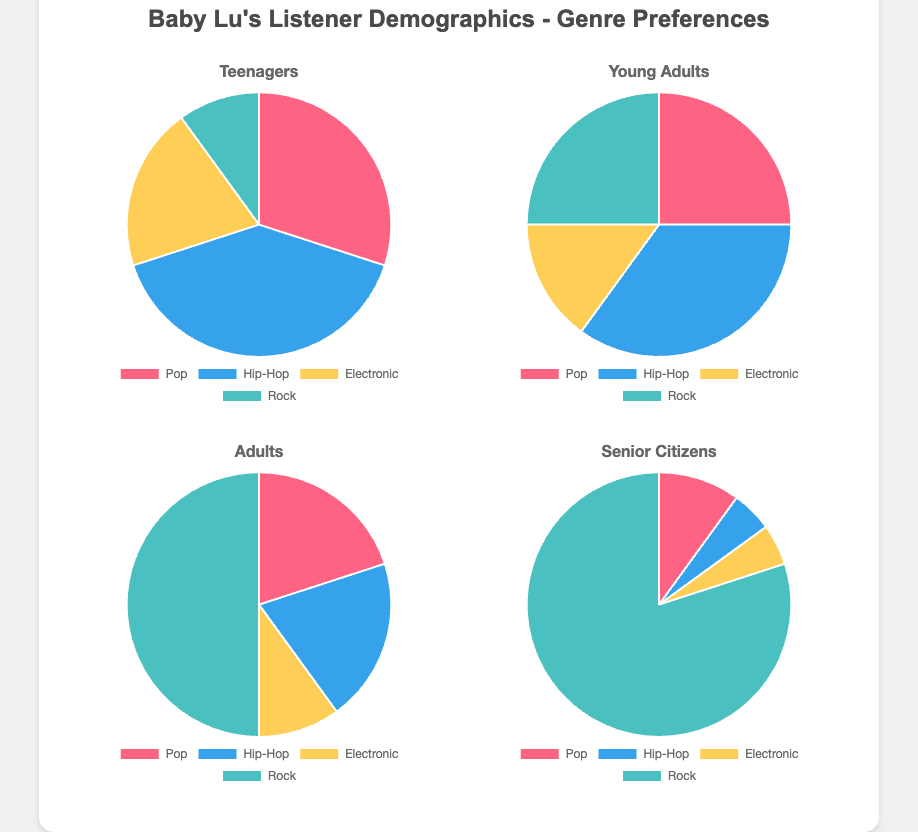What proportion of Teenagers prefer Hip-Hop compared to Rock? To find the proportion, we divide the percentage of Teenagers who prefer Hip-Hop by the percentage who prefer Rock. Hip-Hop preference is 40%, and Rock preference is 10%, so the proportion is 40 / 10 = 4.
Answer: 4 How does the preference for Pop music differ between Young Adults and Senior Citizens? Young Adults have a 25% preference for Pop, while Senior Citizens have a 10% preference. Subtracting the preference of Senior Citizens from Young Adults, we get 25 - 10 = 15.
Answer: 15% What is the combined percentage of Adults who prefer either Electronic or Pop music? The preference for Pop among Adults is 20%, and for Electronic, it is 10%. Adding these percentages together, we get 20 + 10 = 30.
Answer: 30% Which age group has the highest preference for Rock music? By observing the figures, it's clear that Senior Citizens have the highest preference for Rock music at 80%, more than any other age group.
Answer: Senior Citizens What is the average preference for Hip-Hop across all age groups? The Hip-Hop preference percentages are Teenagers (40%), Young Adults (35%), Adults (20%), and Senior Citizens (5%). The average is calculated as (40 + 35 + 20 + 5) / 4 = 100 / 4 = 25.
Answer: 25% Which two genres have the closest preference percentages among Young Adults? Among Young Adults, the preferences are Pop (25%), Hip-Hop (35%), Electronic (15%), and Rock (25%). Pop and Rock both have a preference of 25%, so they are the closest.
Answer: Pop and Rock What percentage of Teenagers prefer genres other than Pop? Teenagers' preferences are Pop (30%), Hip-Hop (40%), Electronic (20%), and Rock (10%). Adding the preferences for genres other than Pop: 40 + 20 + 10 = 70.
Answer: 70% How much more do Adults prefer Rock compared to Electronic music? Adults have a 50% preference for Rock and a 10% preference for Electronic music. Subtracting the two percentages, we get 50 - 10 = 40.
Answer: 40% Between Pop and Hip-Hop, which genre do more Teenagers prefer and by how much? Teenagers have a 30% preference for Pop and a 40% preference for Hip-Hop. The difference is 40 - 30 = 10.
Answer: Hip-Hop by 10% What is the least popular genre among Senior Citizens? Observing the figure, we see that the least popular genre among Senior Citizens is Hip-Hop, with a 5% preference.
Answer: Hip-Hop 